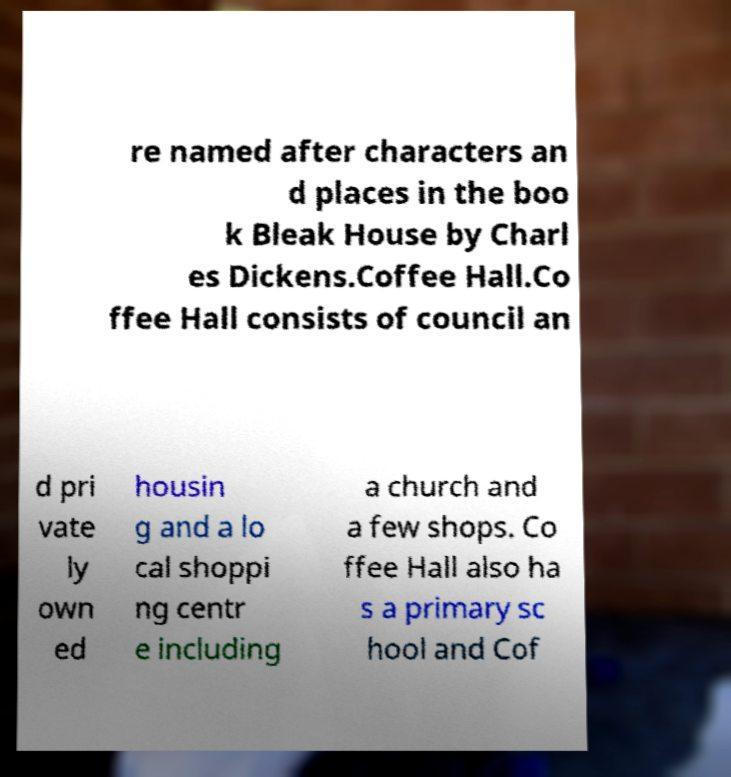Please read and relay the text visible in this image. What does it say? re named after characters an d places in the boo k Bleak House by Charl es Dickens.Coffee Hall.Co ffee Hall consists of council an d pri vate ly own ed housin g and a lo cal shoppi ng centr e including a church and a few shops. Co ffee Hall also ha s a primary sc hool and Cof 